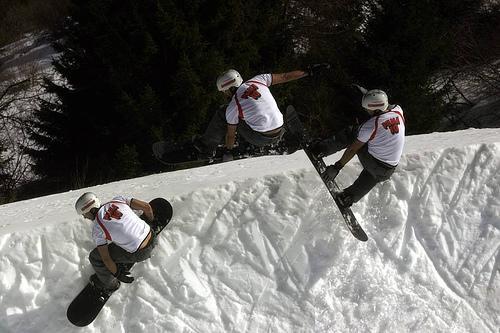How many people are there?
Give a very brief answer. 3. 